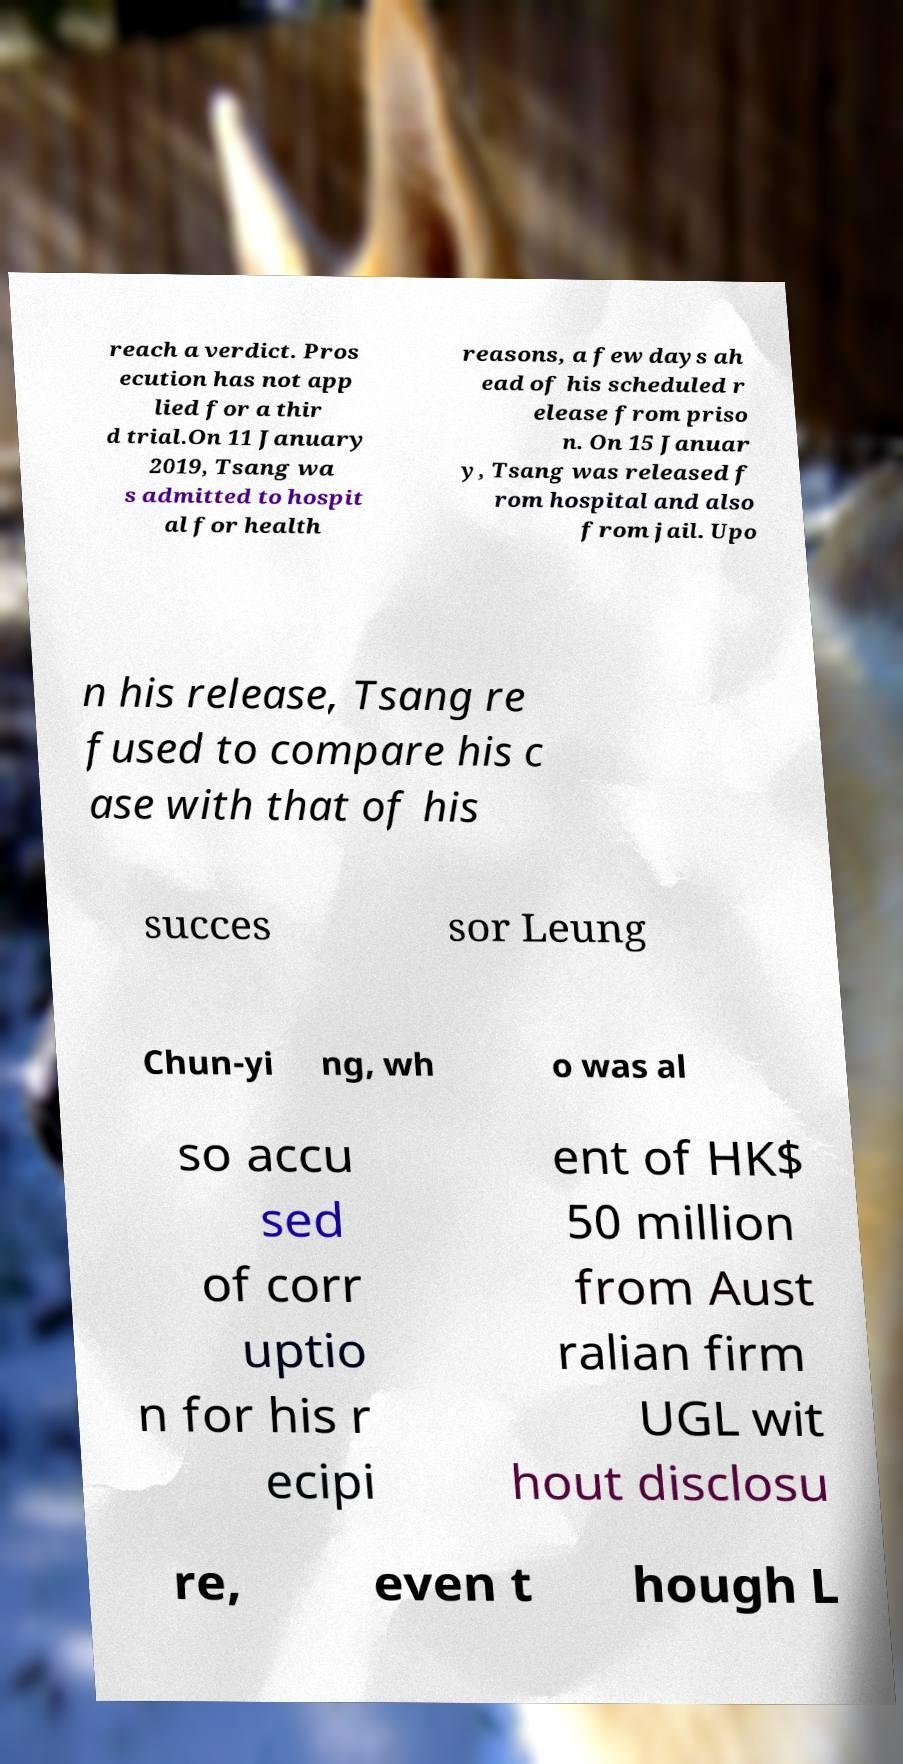Can you read and provide the text displayed in the image?This photo seems to have some interesting text. Can you extract and type it out for me? reach a verdict. Pros ecution has not app lied for a thir d trial.On 11 January 2019, Tsang wa s admitted to hospit al for health reasons, a few days ah ead of his scheduled r elease from priso n. On 15 Januar y, Tsang was released f rom hospital and also from jail. Upo n his release, Tsang re fused to compare his c ase with that of his succes sor Leung Chun-yi ng, wh o was al so accu sed of corr uptio n for his r ecipi ent of HK$ 50 million from Aust ralian firm UGL wit hout disclosu re, even t hough L 